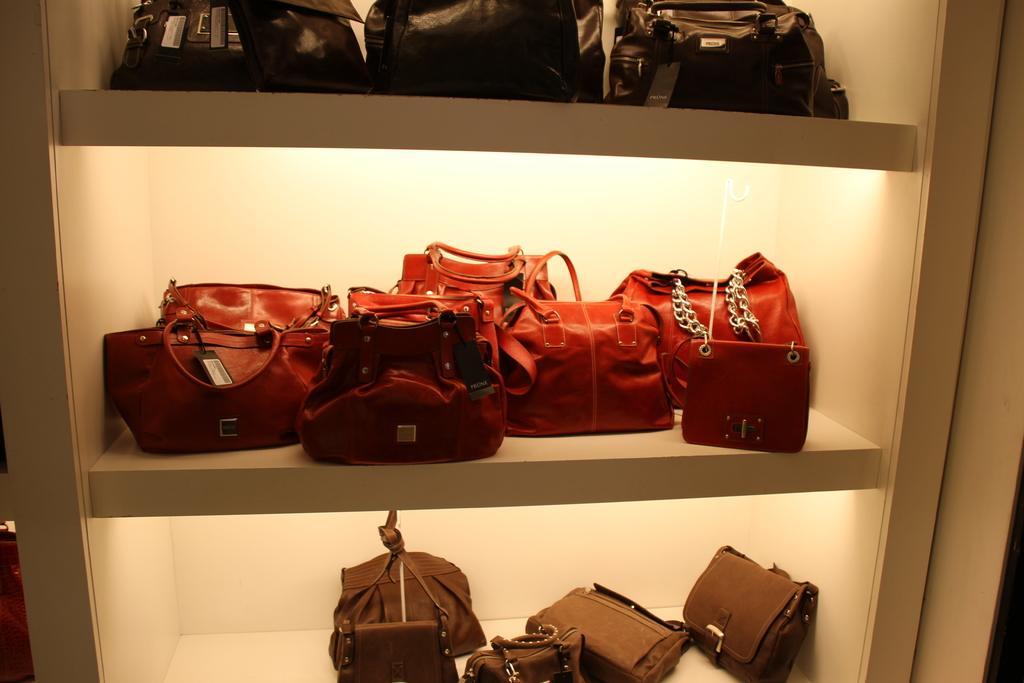In one or two sentences, can you explain what this image depicts? In this image, we can see some shelves, there are some handbags kept on the shelves. 